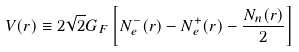<formula> <loc_0><loc_0><loc_500><loc_500>V ( r ) \equiv 2 \sqrt { 2 } G _ { F } \left [ N _ { e } ^ { - } ( r ) - N _ { e } ^ { + } ( r ) - \frac { N _ { n } ( r ) } { 2 } \right ]</formula> 